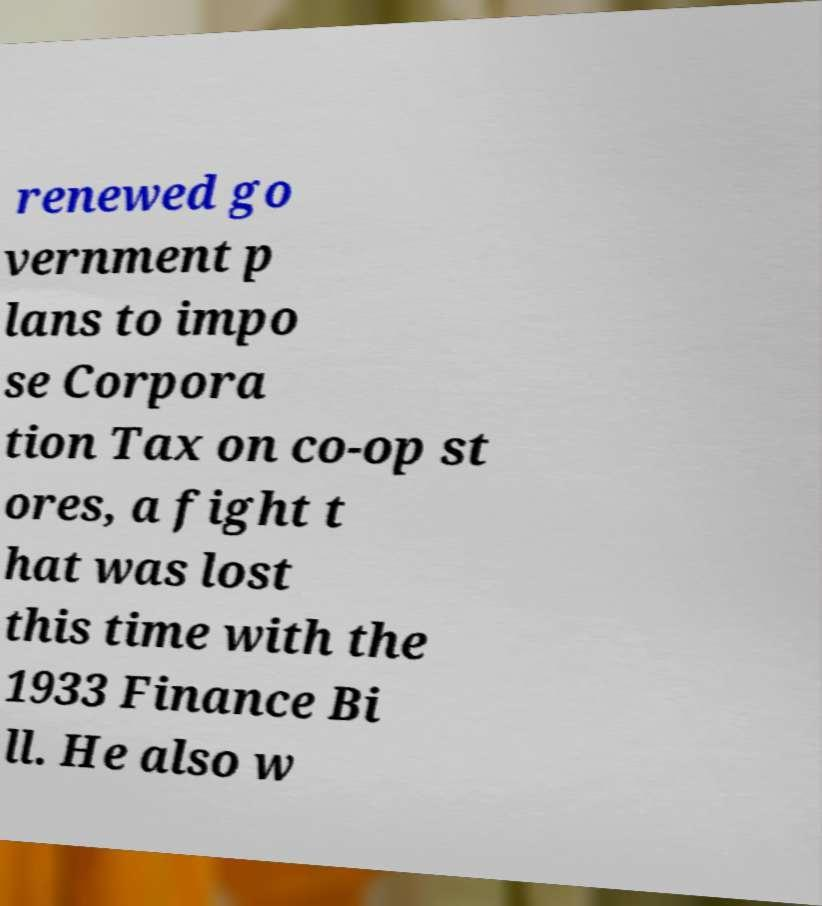Please identify and transcribe the text found in this image. renewed go vernment p lans to impo se Corpora tion Tax on co-op st ores, a fight t hat was lost this time with the 1933 Finance Bi ll. He also w 